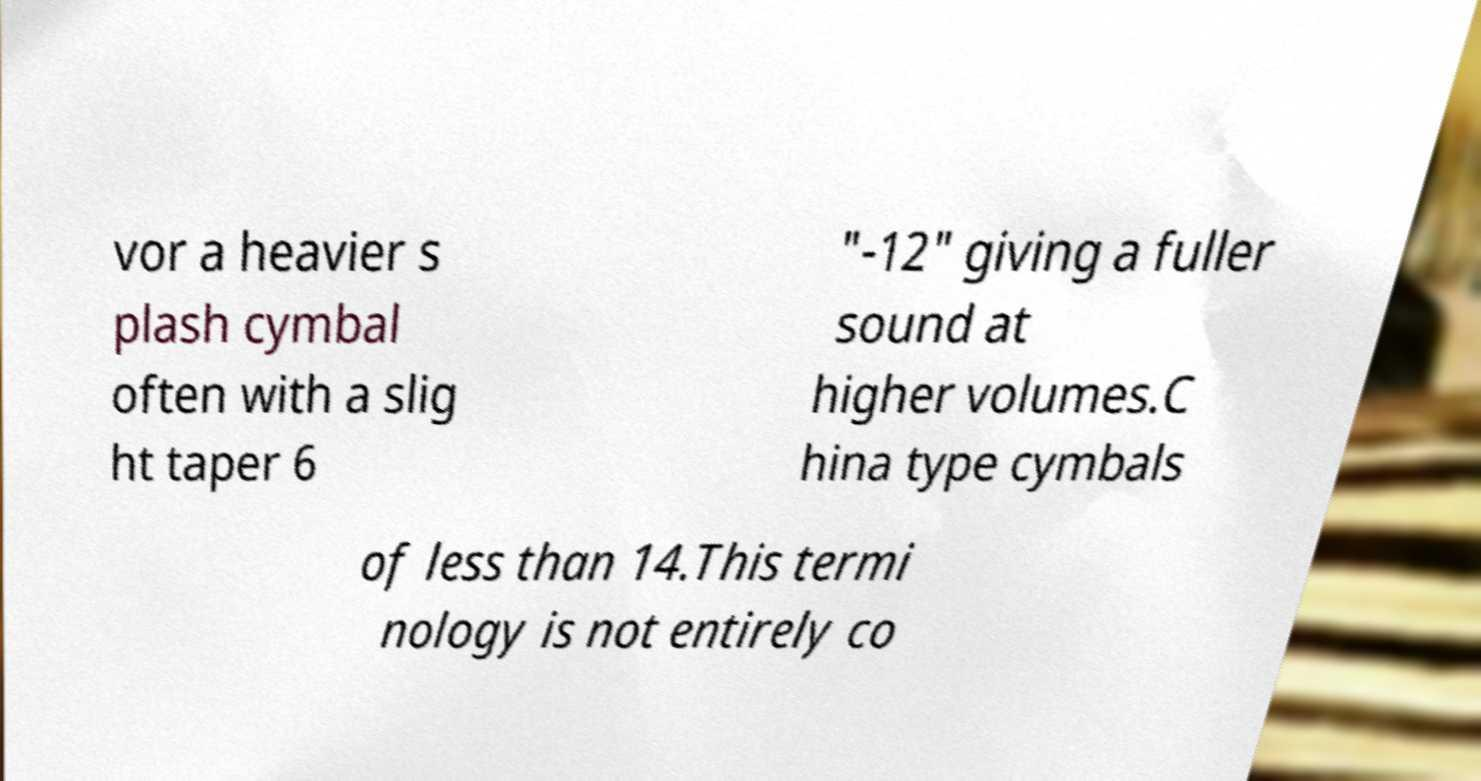I need the written content from this picture converted into text. Can you do that? vor a heavier s plash cymbal often with a slig ht taper 6 "-12" giving a fuller sound at higher volumes.C hina type cymbals of less than 14.This termi nology is not entirely co 